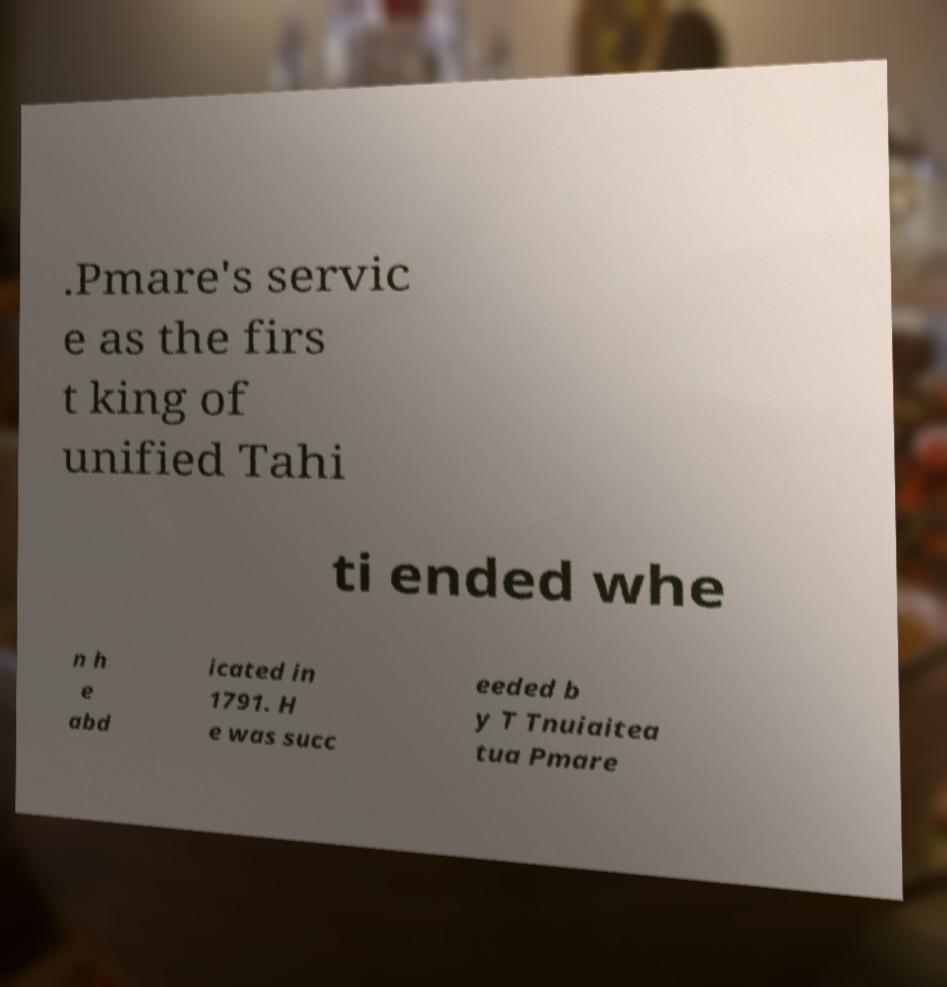I need the written content from this picture converted into text. Can you do that? .Pmare's servic e as the firs t king of unified Tahi ti ended whe n h e abd icated in 1791. H e was succ eeded b y T Tnuiaitea tua Pmare 